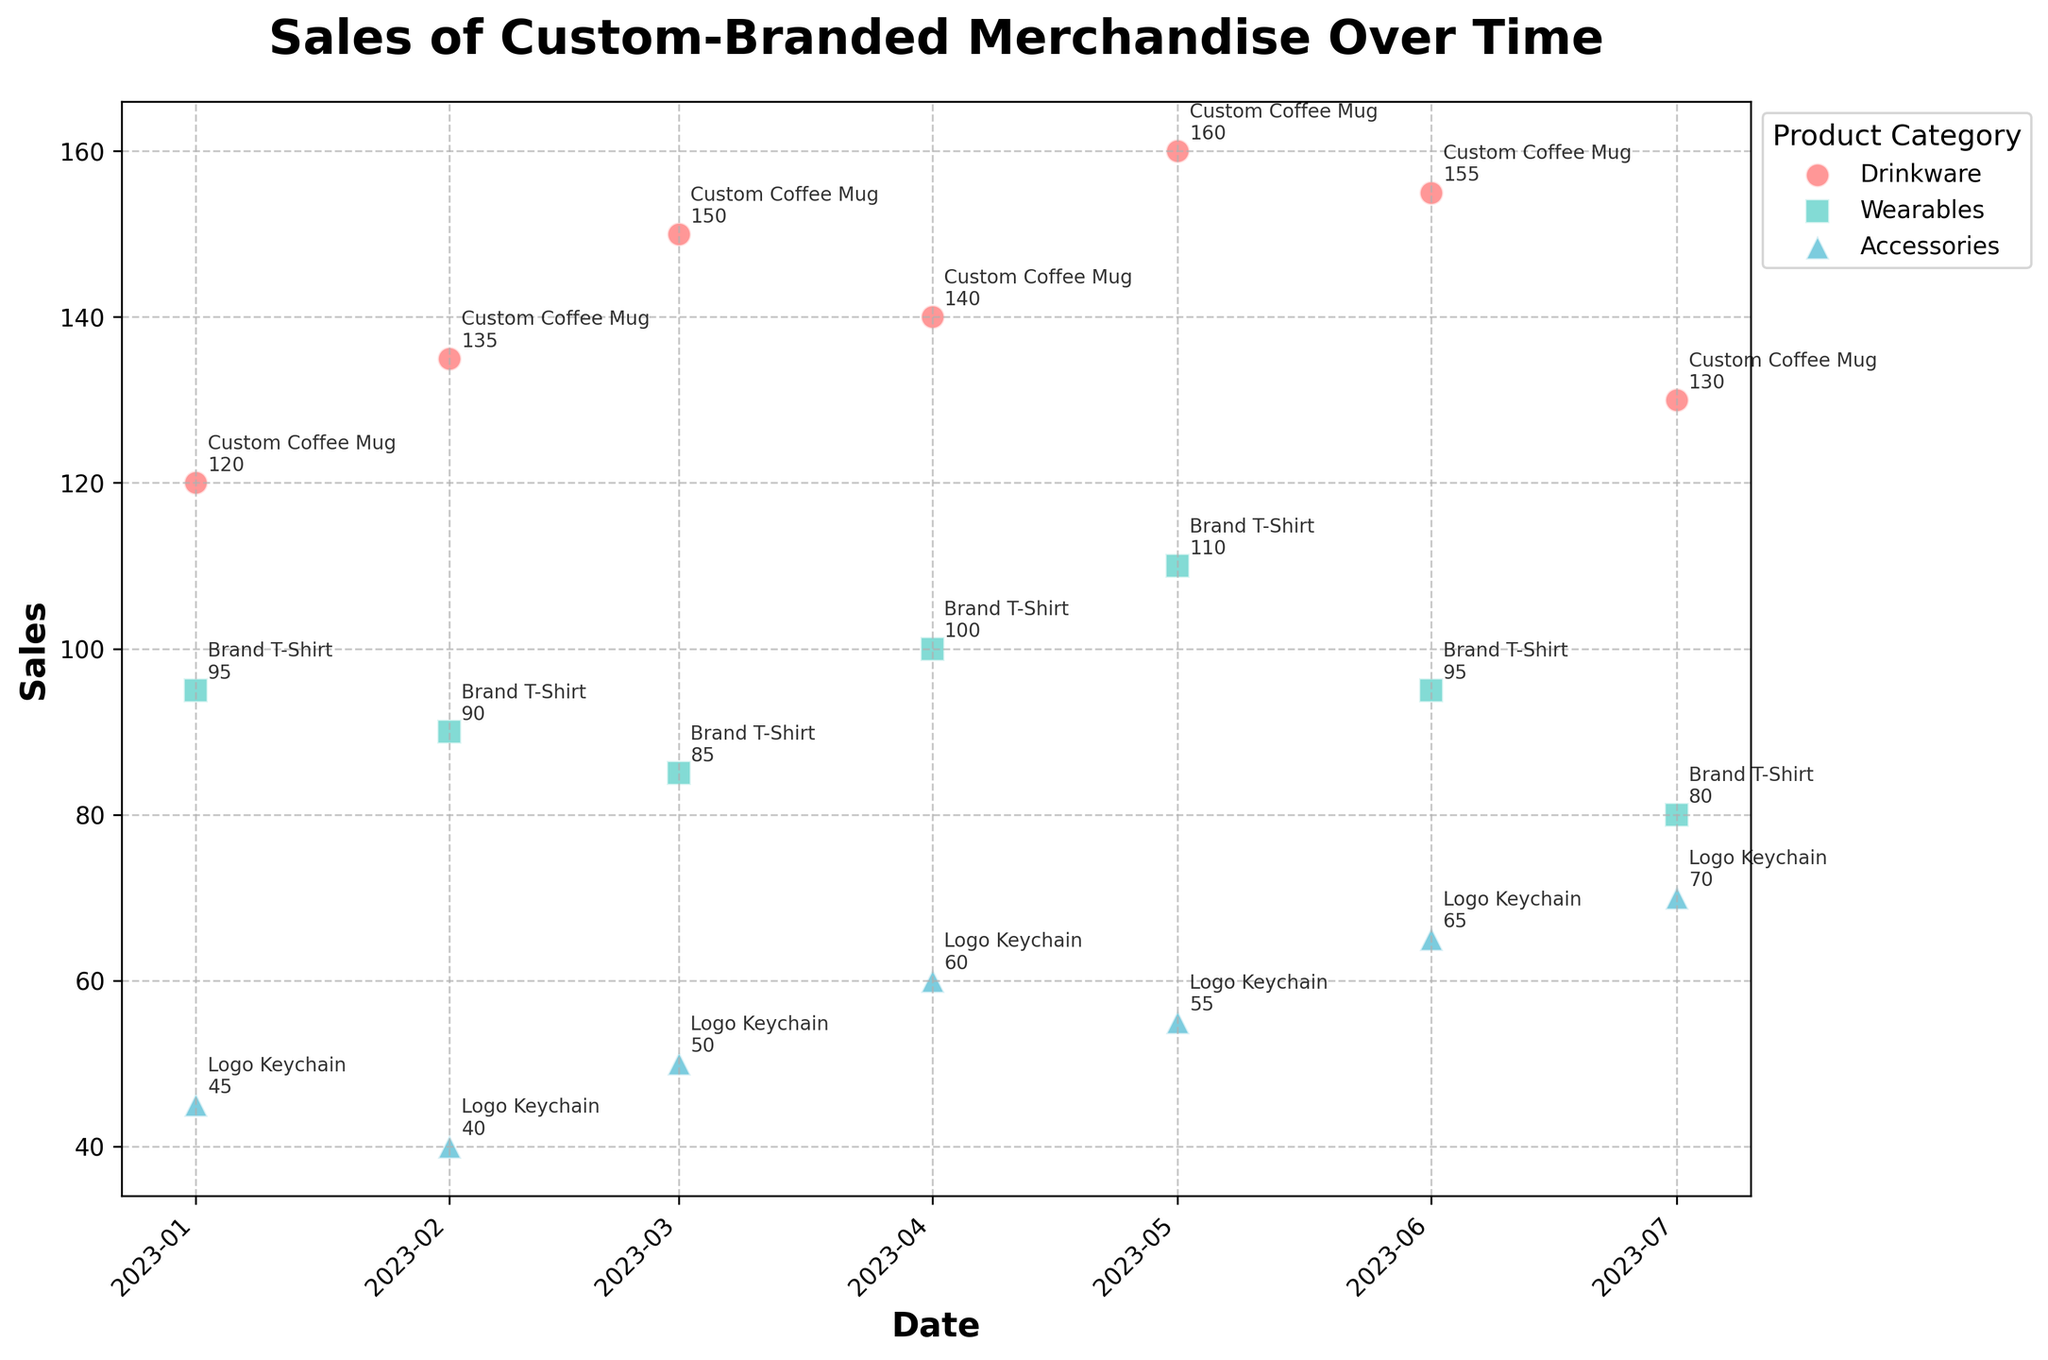What is the title of the plot? The title is located at the top of the plot and is displayed in a large, bold font. It summarizes the main content of the figure.
Answer: Sales of Custom-Branded Merchandise Over Time Which category has the highest sales value in January 2023? Look at the points labeled with the date '2023-01-01' and compare their sales values. The 'Custom Coffee Mug' from the 'Drinkware' category has the highest sales.
Answer: Drinkware What's the range of sales for the 'Brand T-Shirt' over the observed period? Find the highest and lowest sales values for the 'Brand T-Shirt' from the 'Wearables' category. The maximum sales are 110 and the minimum is 80. Subtract the lowest value from the highest. 110 - 80 = 30.
Answer: 30 Which product category shows a general increasing trend in sales over time? Observe the trend of sales points for each product category over time. Notice that for 'Accessories' (Logo Keychain), the sales values tend to increase.
Answer: Accessories How many data points are plotted for the 'Accessories' category? Count the number of scatter points associated with the 'Accessories' category. There is one data point per month from January to July, resulting in a total of 7 data points.
Answer: 7 For 'Drinkware,' which month recorded the highest sales, and what was the value? Look at the sales values for each month in the 'Drinkware' category and identify the highest point. The highest sales were recorded in May 2023 with a sales value of 160.
Answer: May 2023, 160 Between 'Brand T-Shirt' and 'Logo Keychain,' which product had higher sales in June 2023? Compare the sales values for 'Brand T-Shirt' and 'Logo Keychain' in June 2023. 'Logo Keychain' had sales of 65, while 'Brand T-Shirt' had 95, thus 'Brand T-Shirt' had higher sales.
Answer: Brand T-Shirt Which month had the lowest overall sales for the 'Brand T-Shirt'? Review the sales data for 'Brand T-Shirt' across all months and identify the month with the lowest sales value. The lowest sales were in July 2023, with a value of 80.
Answer: July 2023 